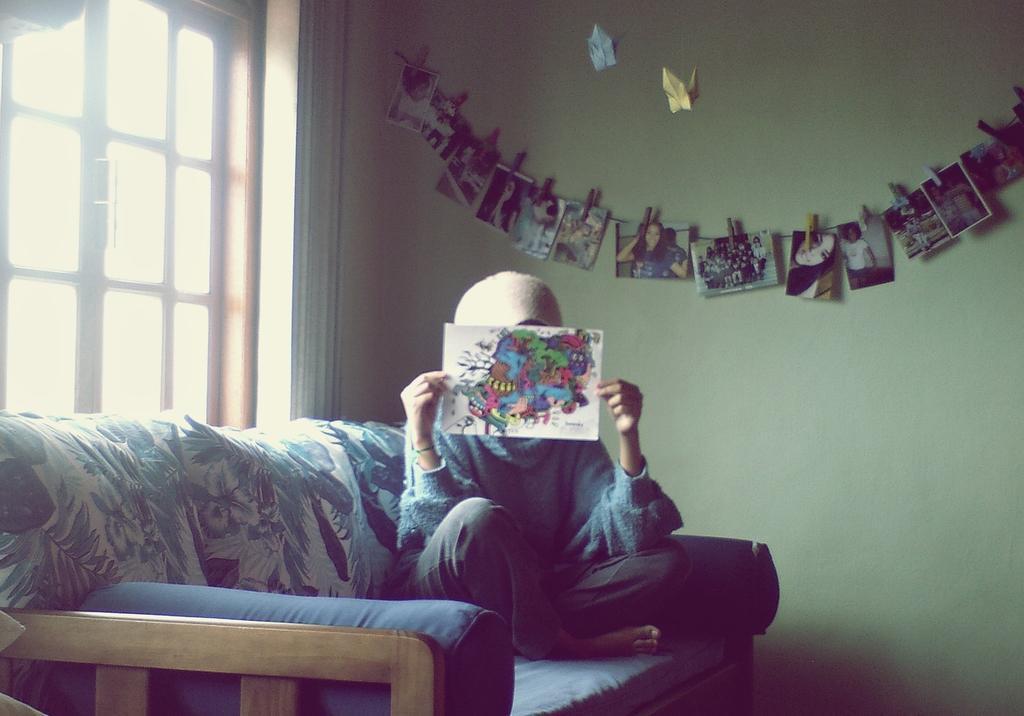Could you give a brief overview of what you see in this image? In the image we can see there is a sofa on which there is a person is sitting and he is holding a white paper on which there are drawings of a cartoon and behind the person there is a green colour wall on which the photographs are hanging to a clip and beside the sofa there is a window. 